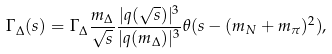<formula> <loc_0><loc_0><loc_500><loc_500>\Gamma _ { \Delta } ( s ) = \Gamma _ { \Delta } \frac { m _ { \Delta } } { \sqrt { s } } \frac { | { q } ( \sqrt { s } ) | ^ { 3 } } { | { q } ( m _ { \Delta } ) | ^ { 3 } } \theta ( s - ( m _ { N } + m _ { \pi } ) ^ { 2 } ) ,</formula> 